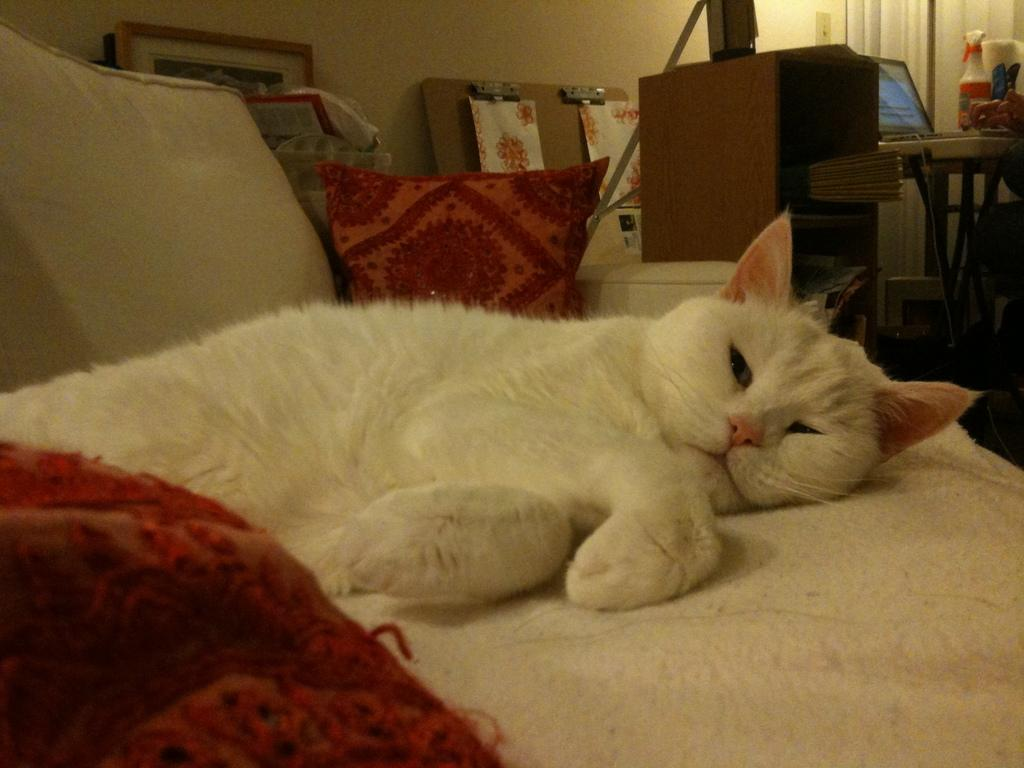What type of animal is in the image? There is a cat in the image. Where is the cat located? The cat is on a couch. What can be seen in the background of the image? There is a photo frame and a laptop in the background of the image. What is the background setting made of? There is a wall visible in the background of the image. How many rings does the cat have on its tail in the image? There are no rings visible on the cat's tail in the image. What type of game is the cat playing on the laptop in the image? There is no game being played on the laptop in the image, as the laptop is in the background and not being used by the cat. 